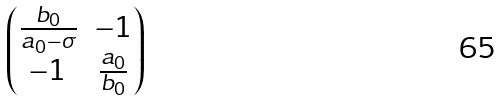Convert formula to latex. <formula><loc_0><loc_0><loc_500><loc_500>\begin{pmatrix} \frac { b _ { 0 } } { a _ { 0 } - \sigma } & - 1 \\ - 1 & \frac { a _ { 0 } } { b _ { 0 } } \end{pmatrix}</formula> 